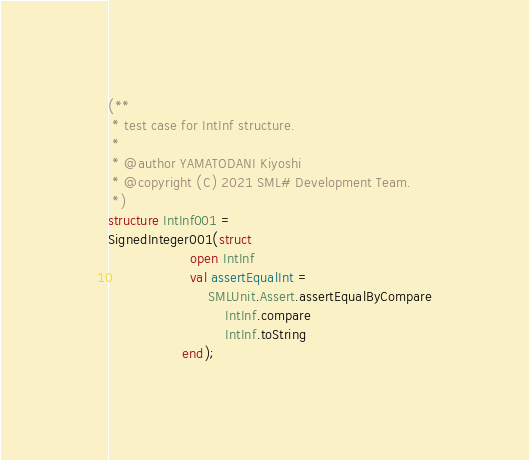Convert code to text. <code><loc_0><loc_0><loc_500><loc_500><_SML_>(**
 * test case for IntInf structure.
 *
 * @author YAMATODANI Kiyoshi
 * @copyright (C) 2021 SML# Development Team.
 *)
structure IntInf001 =
SignedInteger001(struct
                   open IntInf
                   val assertEqualInt =
                       SMLUnit.Assert.assertEqualByCompare
                           IntInf.compare
                           IntInf.toString
                 end);
</code> 